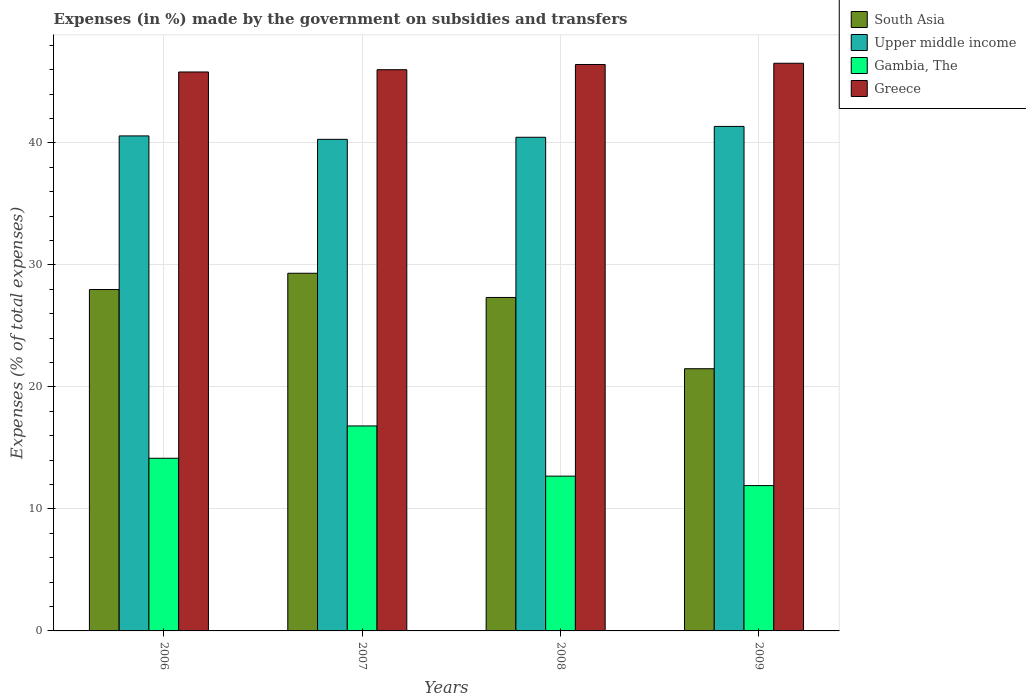How many different coloured bars are there?
Offer a very short reply. 4. How many groups of bars are there?
Give a very brief answer. 4. Are the number of bars per tick equal to the number of legend labels?
Make the answer very short. Yes. Are the number of bars on each tick of the X-axis equal?
Provide a short and direct response. Yes. How many bars are there on the 3rd tick from the right?
Offer a terse response. 4. In how many cases, is the number of bars for a given year not equal to the number of legend labels?
Keep it short and to the point. 0. What is the percentage of expenses made by the government on subsidies and transfers in Upper middle income in 2009?
Ensure brevity in your answer.  41.36. Across all years, what is the maximum percentage of expenses made by the government on subsidies and transfers in Greece?
Make the answer very short. 46.53. Across all years, what is the minimum percentage of expenses made by the government on subsidies and transfers in Gambia, The?
Provide a succinct answer. 11.91. In which year was the percentage of expenses made by the government on subsidies and transfers in Upper middle income maximum?
Your answer should be compact. 2009. In which year was the percentage of expenses made by the government on subsidies and transfers in Upper middle income minimum?
Your response must be concise. 2007. What is the total percentage of expenses made by the government on subsidies and transfers in Upper middle income in the graph?
Give a very brief answer. 162.7. What is the difference between the percentage of expenses made by the government on subsidies and transfers in South Asia in 2006 and that in 2008?
Give a very brief answer. 0.65. What is the difference between the percentage of expenses made by the government on subsidies and transfers in South Asia in 2009 and the percentage of expenses made by the government on subsidies and transfers in Greece in 2006?
Make the answer very short. -24.33. What is the average percentage of expenses made by the government on subsidies and transfers in South Asia per year?
Provide a succinct answer. 26.53. In the year 2006, what is the difference between the percentage of expenses made by the government on subsidies and transfers in Upper middle income and percentage of expenses made by the government on subsidies and transfers in Gambia, The?
Make the answer very short. 26.42. In how many years, is the percentage of expenses made by the government on subsidies and transfers in Gambia, The greater than 6 %?
Make the answer very short. 4. What is the ratio of the percentage of expenses made by the government on subsidies and transfers in Upper middle income in 2007 to that in 2008?
Your response must be concise. 1. What is the difference between the highest and the second highest percentage of expenses made by the government on subsidies and transfers in Greece?
Provide a succinct answer. 0.1. What is the difference between the highest and the lowest percentage of expenses made by the government on subsidies and transfers in South Asia?
Ensure brevity in your answer.  7.83. In how many years, is the percentage of expenses made by the government on subsidies and transfers in South Asia greater than the average percentage of expenses made by the government on subsidies and transfers in South Asia taken over all years?
Your response must be concise. 3. What does the 3rd bar from the left in 2007 represents?
Your response must be concise. Gambia, The. What does the 2nd bar from the right in 2007 represents?
Provide a succinct answer. Gambia, The. Are all the bars in the graph horizontal?
Your answer should be compact. No. How many years are there in the graph?
Your answer should be very brief. 4. What is the difference between two consecutive major ticks on the Y-axis?
Your response must be concise. 10. Does the graph contain any zero values?
Provide a succinct answer. No. Does the graph contain grids?
Your response must be concise. Yes. How many legend labels are there?
Keep it short and to the point. 4. How are the legend labels stacked?
Your answer should be compact. Vertical. What is the title of the graph?
Your answer should be very brief. Expenses (in %) made by the government on subsidies and transfers. What is the label or title of the X-axis?
Make the answer very short. Years. What is the label or title of the Y-axis?
Provide a short and direct response. Expenses (% of total expenses). What is the Expenses (% of total expenses) in South Asia in 2006?
Provide a short and direct response. 27.99. What is the Expenses (% of total expenses) of Upper middle income in 2006?
Ensure brevity in your answer.  40.58. What is the Expenses (% of total expenses) in Gambia, The in 2006?
Your response must be concise. 14.15. What is the Expenses (% of total expenses) of Greece in 2006?
Your response must be concise. 45.82. What is the Expenses (% of total expenses) in South Asia in 2007?
Offer a terse response. 29.32. What is the Expenses (% of total expenses) of Upper middle income in 2007?
Give a very brief answer. 40.3. What is the Expenses (% of total expenses) of Gambia, The in 2007?
Your answer should be compact. 16.8. What is the Expenses (% of total expenses) in Greece in 2007?
Your response must be concise. 46. What is the Expenses (% of total expenses) in South Asia in 2008?
Ensure brevity in your answer.  27.33. What is the Expenses (% of total expenses) in Upper middle income in 2008?
Offer a very short reply. 40.47. What is the Expenses (% of total expenses) in Gambia, The in 2008?
Your response must be concise. 12.69. What is the Expenses (% of total expenses) of Greece in 2008?
Give a very brief answer. 46.43. What is the Expenses (% of total expenses) in South Asia in 2009?
Give a very brief answer. 21.49. What is the Expenses (% of total expenses) in Upper middle income in 2009?
Your answer should be very brief. 41.36. What is the Expenses (% of total expenses) of Gambia, The in 2009?
Your response must be concise. 11.91. What is the Expenses (% of total expenses) in Greece in 2009?
Keep it short and to the point. 46.53. Across all years, what is the maximum Expenses (% of total expenses) in South Asia?
Offer a very short reply. 29.32. Across all years, what is the maximum Expenses (% of total expenses) in Upper middle income?
Provide a short and direct response. 41.36. Across all years, what is the maximum Expenses (% of total expenses) in Gambia, The?
Your response must be concise. 16.8. Across all years, what is the maximum Expenses (% of total expenses) in Greece?
Keep it short and to the point. 46.53. Across all years, what is the minimum Expenses (% of total expenses) in South Asia?
Keep it short and to the point. 21.49. Across all years, what is the minimum Expenses (% of total expenses) in Upper middle income?
Your answer should be very brief. 40.3. Across all years, what is the minimum Expenses (% of total expenses) in Gambia, The?
Provide a short and direct response. 11.91. Across all years, what is the minimum Expenses (% of total expenses) of Greece?
Your response must be concise. 45.82. What is the total Expenses (% of total expenses) of South Asia in the graph?
Ensure brevity in your answer.  106.13. What is the total Expenses (% of total expenses) in Upper middle income in the graph?
Give a very brief answer. 162.7. What is the total Expenses (% of total expenses) in Gambia, The in the graph?
Your response must be concise. 55.56. What is the total Expenses (% of total expenses) in Greece in the graph?
Provide a short and direct response. 184.79. What is the difference between the Expenses (% of total expenses) in South Asia in 2006 and that in 2007?
Ensure brevity in your answer.  -1.33. What is the difference between the Expenses (% of total expenses) of Upper middle income in 2006 and that in 2007?
Make the answer very short. 0.28. What is the difference between the Expenses (% of total expenses) of Gambia, The in 2006 and that in 2007?
Provide a short and direct response. -2.65. What is the difference between the Expenses (% of total expenses) of Greece in 2006 and that in 2007?
Provide a succinct answer. -0.19. What is the difference between the Expenses (% of total expenses) in South Asia in 2006 and that in 2008?
Provide a short and direct response. 0.65. What is the difference between the Expenses (% of total expenses) in Upper middle income in 2006 and that in 2008?
Provide a short and direct response. 0.11. What is the difference between the Expenses (% of total expenses) in Gambia, The in 2006 and that in 2008?
Keep it short and to the point. 1.47. What is the difference between the Expenses (% of total expenses) in Greece in 2006 and that in 2008?
Keep it short and to the point. -0.61. What is the difference between the Expenses (% of total expenses) of South Asia in 2006 and that in 2009?
Your response must be concise. 6.49. What is the difference between the Expenses (% of total expenses) of Upper middle income in 2006 and that in 2009?
Give a very brief answer. -0.78. What is the difference between the Expenses (% of total expenses) in Gambia, The in 2006 and that in 2009?
Your answer should be compact. 2.24. What is the difference between the Expenses (% of total expenses) of Greece in 2006 and that in 2009?
Your answer should be very brief. -0.71. What is the difference between the Expenses (% of total expenses) of South Asia in 2007 and that in 2008?
Offer a terse response. 1.98. What is the difference between the Expenses (% of total expenses) in Upper middle income in 2007 and that in 2008?
Your response must be concise. -0.17. What is the difference between the Expenses (% of total expenses) in Gambia, The in 2007 and that in 2008?
Offer a terse response. 4.11. What is the difference between the Expenses (% of total expenses) in Greece in 2007 and that in 2008?
Ensure brevity in your answer.  -0.43. What is the difference between the Expenses (% of total expenses) in South Asia in 2007 and that in 2009?
Offer a terse response. 7.83. What is the difference between the Expenses (% of total expenses) in Upper middle income in 2007 and that in 2009?
Your response must be concise. -1.06. What is the difference between the Expenses (% of total expenses) in Gambia, The in 2007 and that in 2009?
Offer a very short reply. 4.89. What is the difference between the Expenses (% of total expenses) in Greece in 2007 and that in 2009?
Give a very brief answer. -0.53. What is the difference between the Expenses (% of total expenses) of South Asia in 2008 and that in 2009?
Your answer should be very brief. 5.84. What is the difference between the Expenses (% of total expenses) in Upper middle income in 2008 and that in 2009?
Your answer should be compact. -0.89. What is the difference between the Expenses (% of total expenses) of Gambia, The in 2008 and that in 2009?
Keep it short and to the point. 0.77. What is the difference between the Expenses (% of total expenses) in Greece in 2008 and that in 2009?
Offer a very short reply. -0.1. What is the difference between the Expenses (% of total expenses) in South Asia in 2006 and the Expenses (% of total expenses) in Upper middle income in 2007?
Make the answer very short. -12.31. What is the difference between the Expenses (% of total expenses) of South Asia in 2006 and the Expenses (% of total expenses) of Gambia, The in 2007?
Provide a short and direct response. 11.18. What is the difference between the Expenses (% of total expenses) of South Asia in 2006 and the Expenses (% of total expenses) of Greece in 2007?
Offer a terse response. -18.02. What is the difference between the Expenses (% of total expenses) in Upper middle income in 2006 and the Expenses (% of total expenses) in Gambia, The in 2007?
Provide a short and direct response. 23.77. What is the difference between the Expenses (% of total expenses) in Upper middle income in 2006 and the Expenses (% of total expenses) in Greece in 2007?
Keep it short and to the point. -5.43. What is the difference between the Expenses (% of total expenses) of Gambia, The in 2006 and the Expenses (% of total expenses) of Greece in 2007?
Keep it short and to the point. -31.85. What is the difference between the Expenses (% of total expenses) in South Asia in 2006 and the Expenses (% of total expenses) in Upper middle income in 2008?
Your answer should be very brief. -12.48. What is the difference between the Expenses (% of total expenses) in South Asia in 2006 and the Expenses (% of total expenses) in Gambia, The in 2008?
Give a very brief answer. 15.3. What is the difference between the Expenses (% of total expenses) of South Asia in 2006 and the Expenses (% of total expenses) of Greece in 2008?
Keep it short and to the point. -18.45. What is the difference between the Expenses (% of total expenses) in Upper middle income in 2006 and the Expenses (% of total expenses) in Gambia, The in 2008?
Your response must be concise. 27.89. What is the difference between the Expenses (% of total expenses) in Upper middle income in 2006 and the Expenses (% of total expenses) in Greece in 2008?
Provide a succinct answer. -5.86. What is the difference between the Expenses (% of total expenses) of Gambia, The in 2006 and the Expenses (% of total expenses) of Greece in 2008?
Offer a very short reply. -32.28. What is the difference between the Expenses (% of total expenses) of South Asia in 2006 and the Expenses (% of total expenses) of Upper middle income in 2009?
Your response must be concise. -13.37. What is the difference between the Expenses (% of total expenses) of South Asia in 2006 and the Expenses (% of total expenses) of Gambia, The in 2009?
Provide a short and direct response. 16.07. What is the difference between the Expenses (% of total expenses) of South Asia in 2006 and the Expenses (% of total expenses) of Greece in 2009?
Your answer should be very brief. -18.55. What is the difference between the Expenses (% of total expenses) in Upper middle income in 2006 and the Expenses (% of total expenses) in Gambia, The in 2009?
Give a very brief answer. 28.66. What is the difference between the Expenses (% of total expenses) in Upper middle income in 2006 and the Expenses (% of total expenses) in Greece in 2009?
Your answer should be compact. -5.96. What is the difference between the Expenses (% of total expenses) in Gambia, The in 2006 and the Expenses (% of total expenses) in Greece in 2009?
Make the answer very short. -32.38. What is the difference between the Expenses (% of total expenses) of South Asia in 2007 and the Expenses (% of total expenses) of Upper middle income in 2008?
Your answer should be very brief. -11.15. What is the difference between the Expenses (% of total expenses) of South Asia in 2007 and the Expenses (% of total expenses) of Gambia, The in 2008?
Offer a very short reply. 16.63. What is the difference between the Expenses (% of total expenses) of South Asia in 2007 and the Expenses (% of total expenses) of Greece in 2008?
Ensure brevity in your answer.  -17.11. What is the difference between the Expenses (% of total expenses) in Upper middle income in 2007 and the Expenses (% of total expenses) in Gambia, The in 2008?
Ensure brevity in your answer.  27.61. What is the difference between the Expenses (% of total expenses) in Upper middle income in 2007 and the Expenses (% of total expenses) in Greece in 2008?
Provide a succinct answer. -6.13. What is the difference between the Expenses (% of total expenses) of Gambia, The in 2007 and the Expenses (% of total expenses) of Greece in 2008?
Provide a succinct answer. -29.63. What is the difference between the Expenses (% of total expenses) of South Asia in 2007 and the Expenses (% of total expenses) of Upper middle income in 2009?
Keep it short and to the point. -12.04. What is the difference between the Expenses (% of total expenses) of South Asia in 2007 and the Expenses (% of total expenses) of Gambia, The in 2009?
Offer a very short reply. 17.41. What is the difference between the Expenses (% of total expenses) in South Asia in 2007 and the Expenses (% of total expenses) in Greece in 2009?
Provide a short and direct response. -17.21. What is the difference between the Expenses (% of total expenses) of Upper middle income in 2007 and the Expenses (% of total expenses) of Gambia, The in 2009?
Make the answer very short. 28.38. What is the difference between the Expenses (% of total expenses) in Upper middle income in 2007 and the Expenses (% of total expenses) in Greece in 2009?
Your answer should be compact. -6.24. What is the difference between the Expenses (% of total expenses) of Gambia, The in 2007 and the Expenses (% of total expenses) of Greece in 2009?
Give a very brief answer. -29.73. What is the difference between the Expenses (% of total expenses) of South Asia in 2008 and the Expenses (% of total expenses) of Upper middle income in 2009?
Provide a succinct answer. -14.02. What is the difference between the Expenses (% of total expenses) of South Asia in 2008 and the Expenses (% of total expenses) of Gambia, The in 2009?
Offer a terse response. 15.42. What is the difference between the Expenses (% of total expenses) of South Asia in 2008 and the Expenses (% of total expenses) of Greece in 2009?
Make the answer very short. -19.2. What is the difference between the Expenses (% of total expenses) of Upper middle income in 2008 and the Expenses (% of total expenses) of Gambia, The in 2009?
Offer a terse response. 28.55. What is the difference between the Expenses (% of total expenses) of Upper middle income in 2008 and the Expenses (% of total expenses) of Greece in 2009?
Your answer should be very brief. -6.07. What is the difference between the Expenses (% of total expenses) of Gambia, The in 2008 and the Expenses (% of total expenses) of Greece in 2009?
Provide a short and direct response. -33.85. What is the average Expenses (% of total expenses) in South Asia per year?
Ensure brevity in your answer.  26.53. What is the average Expenses (% of total expenses) in Upper middle income per year?
Your answer should be compact. 40.67. What is the average Expenses (% of total expenses) of Gambia, The per year?
Provide a short and direct response. 13.89. What is the average Expenses (% of total expenses) of Greece per year?
Offer a very short reply. 46.2. In the year 2006, what is the difference between the Expenses (% of total expenses) in South Asia and Expenses (% of total expenses) in Upper middle income?
Your answer should be compact. -12.59. In the year 2006, what is the difference between the Expenses (% of total expenses) in South Asia and Expenses (% of total expenses) in Gambia, The?
Provide a succinct answer. 13.83. In the year 2006, what is the difference between the Expenses (% of total expenses) of South Asia and Expenses (% of total expenses) of Greece?
Your answer should be very brief. -17.83. In the year 2006, what is the difference between the Expenses (% of total expenses) in Upper middle income and Expenses (% of total expenses) in Gambia, The?
Give a very brief answer. 26.42. In the year 2006, what is the difference between the Expenses (% of total expenses) of Upper middle income and Expenses (% of total expenses) of Greece?
Your response must be concise. -5.24. In the year 2006, what is the difference between the Expenses (% of total expenses) in Gambia, The and Expenses (% of total expenses) in Greece?
Your answer should be compact. -31.66. In the year 2007, what is the difference between the Expenses (% of total expenses) of South Asia and Expenses (% of total expenses) of Upper middle income?
Your response must be concise. -10.98. In the year 2007, what is the difference between the Expenses (% of total expenses) of South Asia and Expenses (% of total expenses) of Gambia, The?
Give a very brief answer. 12.52. In the year 2007, what is the difference between the Expenses (% of total expenses) in South Asia and Expenses (% of total expenses) in Greece?
Give a very brief answer. -16.69. In the year 2007, what is the difference between the Expenses (% of total expenses) in Upper middle income and Expenses (% of total expenses) in Gambia, The?
Provide a short and direct response. 23.49. In the year 2007, what is the difference between the Expenses (% of total expenses) in Upper middle income and Expenses (% of total expenses) in Greece?
Offer a terse response. -5.71. In the year 2007, what is the difference between the Expenses (% of total expenses) in Gambia, The and Expenses (% of total expenses) in Greece?
Keep it short and to the point. -29.2. In the year 2008, what is the difference between the Expenses (% of total expenses) in South Asia and Expenses (% of total expenses) in Upper middle income?
Your answer should be compact. -13.13. In the year 2008, what is the difference between the Expenses (% of total expenses) of South Asia and Expenses (% of total expenses) of Gambia, The?
Keep it short and to the point. 14.65. In the year 2008, what is the difference between the Expenses (% of total expenses) in South Asia and Expenses (% of total expenses) in Greece?
Your response must be concise. -19.1. In the year 2008, what is the difference between the Expenses (% of total expenses) in Upper middle income and Expenses (% of total expenses) in Gambia, The?
Keep it short and to the point. 27.78. In the year 2008, what is the difference between the Expenses (% of total expenses) of Upper middle income and Expenses (% of total expenses) of Greece?
Keep it short and to the point. -5.97. In the year 2008, what is the difference between the Expenses (% of total expenses) in Gambia, The and Expenses (% of total expenses) in Greece?
Your answer should be very brief. -33.74. In the year 2009, what is the difference between the Expenses (% of total expenses) in South Asia and Expenses (% of total expenses) in Upper middle income?
Provide a succinct answer. -19.86. In the year 2009, what is the difference between the Expenses (% of total expenses) in South Asia and Expenses (% of total expenses) in Gambia, The?
Your answer should be compact. 9.58. In the year 2009, what is the difference between the Expenses (% of total expenses) of South Asia and Expenses (% of total expenses) of Greece?
Give a very brief answer. -25.04. In the year 2009, what is the difference between the Expenses (% of total expenses) in Upper middle income and Expenses (% of total expenses) in Gambia, The?
Ensure brevity in your answer.  29.44. In the year 2009, what is the difference between the Expenses (% of total expenses) of Upper middle income and Expenses (% of total expenses) of Greece?
Make the answer very short. -5.18. In the year 2009, what is the difference between the Expenses (% of total expenses) in Gambia, The and Expenses (% of total expenses) in Greece?
Provide a succinct answer. -34.62. What is the ratio of the Expenses (% of total expenses) of South Asia in 2006 to that in 2007?
Your answer should be very brief. 0.95. What is the ratio of the Expenses (% of total expenses) in Gambia, The in 2006 to that in 2007?
Provide a succinct answer. 0.84. What is the ratio of the Expenses (% of total expenses) of South Asia in 2006 to that in 2008?
Give a very brief answer. 1.02. What is the ratio of the Expenses (% of total expenses) of Upper middle income in 2006 to that in 2008?
Your response must be concise. 1. What is the ratio of the Expenses (% of total expenses) of Gambia, The in 2006 to that in 2008?
Provide a short and direct response. 1.12. What is the ratio of the Expenses (% of total expenses) in Greece in 2006 to that in 2008?
Ensure brevity in your answer.  0.99. What is the ratio of the Expenses (% of total expenses) of South Asia in 2006 to that in 2009?
Make the answer very short. 1.3. What is the ratio of the Expenses (% of total expenses) of Upper middle income in 2006 to that in 2009?
Offer a very short reply. 0.98. What is the ratio of the Expenses (% of total expenses) in Gambia, The in 2006 to that in 2009?
Keep it short and to the point. 1.19. What is the ratio of the Expenses (% of total expenses) in Greece in 2006 to that in 2009?
Offer a terse response. 0.98. What is the ratio of the Expenses (% of total expenses) in South Asia in 2007 to that in 2008?
Provide a short and direct response. 1.07. What is the ratio of the Expenses (% of total expenses) in Gambia, The in 2007 to that in 2008?
Offer a terse response. 1.32. What is the ratio of the Expenses (% of total expenses) in Greece in 2007 to that in 2008?
Provide a succinct answer. 0.99. What is the ratio of the Expenses (% of total expenses) of South Asia in 2007 to that in 2009?
Give a very brief answer. 1.36. What is the ratio of the Expenses (% of total expenses) of Upper middle income in 2007 to that in 2009?
Your answer should be compact. 0.97. What is the ratio of the Expenses (% of total expenses) of Gambia, The in 2007 to that in 2009?
Give a very brief answer. 1.41. What is the ratio of the Expenses (% of total expenses) of South Asia in 2008 to that in 2009?
Make the answer very short. 1.27. What is the ratio of the Expenses (% of total expenses) of Upper middle income in 2008 to that in 2009?
Offer a terse response. 0.98. What is the ratio of the Expenses (% of total expenses) in Gambia, The in 2008 to that in 2009?
Ensure brevity in your answer.  1.06. What is the difference between the highest and the second highest Expenses (% of total expenses) in South Asia?
Provide a short and direct response. 1.33. What is the difference between the highest and the second highest Expenses (% of total expenses) in Upper middle income?
Make the answer very short. 0.78. What is the difference between the highest and the second highest Expenses (% of total expenses) of Gambia, The?
Provide a succinct answer. 2.65. What is the difference between the highest and the second highest Expenses (% of total expenses) of Greece?
Provide a short and direct response. 0.1. What is the difference between the highest and the lowest Expenses (% of total expenses) in South Asia?
Offer a terse response. 7.83. What is the difference between the highest and the lowest Expenses (% of total expenses) of Upper middle income?
Make the answer very short. 1.06. What is the difference between the highest and the lowest Expenses (% of total expenses) in Gambia, The?
Provide a succinct answer. 4.89. What is the difference between the highest and the lowest Expenses (% of total expenses) in Greece?
Offer a terse response. 0.71. 